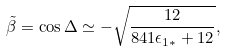<formula> <loc_0><loc_0><loc_500><loc_500>\tilde { \beta } = \cos \Delta \simeq - \sqrt { \frac { 1 2 } { 8 4 1 \epsilon _ { 1 \ast } + 1 2 } } ,</formula> 